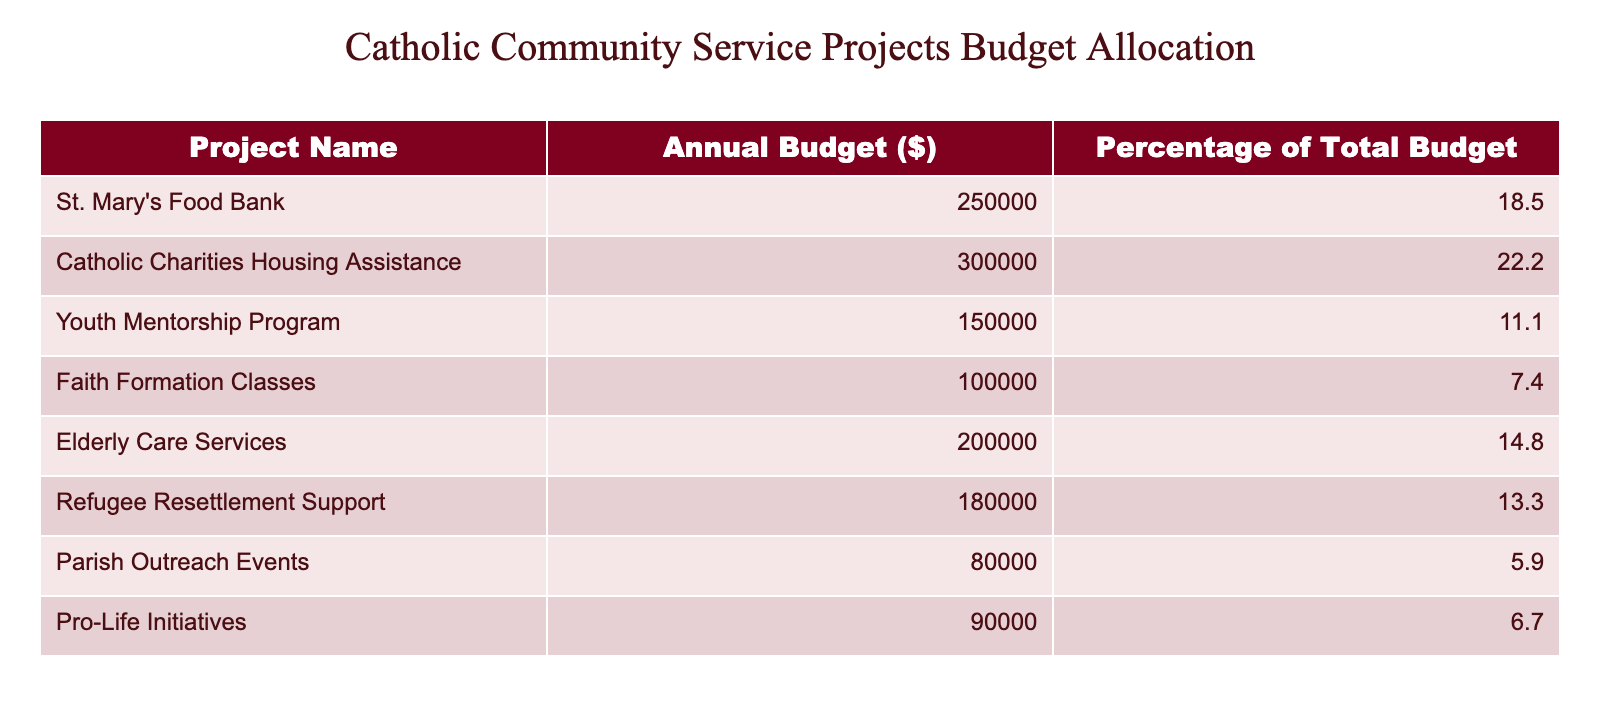What is the annual budget for St. Mary's Food Bank? The table indicates that the annual budget for St. Mary's Food Bank is listed directly in the relevant row.
Answer: 250000 Which project has the highest annual budget? By reviewing the annual budgets listed for each project, Catholic Charities Housing Assistance has the highest budget at 300000.
Answer: 300000 What percentage of the total budget is allocated to the Youth Mentorship Program? The table states that the Youth Mentorship Program has a budget allocation of 150000, which corresponds to 11.1% of the total budget as seen in the relevant cell.
Answer: 11.1% If we combine the budgets of Elderly Care Services and Pro-Life Initiatives, what is the total? To find the total budget for these two projects, add their individual budgets: 200000 (Elderly Care Services) + 90000 (Pro-Life Initiatives) = 290000.
Answer: 290000 Is the budget for Refugee Resettlement Support greater than that for Pro-Life Initiatives? The table shows that the budget for Refugee Resettlement Support is 180000, while for Pro-Life Initiatives, it is 90000. Since 180000 is greater than 90000, the statement is true.
Answer: Yes What is the average budget allocation of all the projects listed? First, sum up all the annual budgets: 250000 + 300000 + 150000 + 100000 + 200000 + 180000 + 80000 + 90000 = 1360000. There are 8 projects, so divide the total by 8: 1360000 / 8 = 170000.
Answer: 170000 Is the combined budget of Faith Formation Classes and Parish Outreach Events less than 200000? The budget for Faith Formation Classes is 100000 and for Parish Outreach Events, it is 80000. Adding these together results in 100000 + 80000 = 180000, which is less than 200000.
Answer: Yes What is the difference in budget between the highest and lowest funded projects? The highest budget is for Catholic Charities Housing Assistance at 300000, and the lowest is for Parish Outreach Events at 80000. The difference is 300000 - 80000 = 220000.
Answer: 220000 How much of the total budget is allocated for food-related services? There are two projects related to food: St. Mary's Food Bank (250000) and the Youth Mentorship Program (not food-related, so only St. Mary's) which totals to 250000, representing that budget percentage against the total needs calculation.
Answer: 250000 